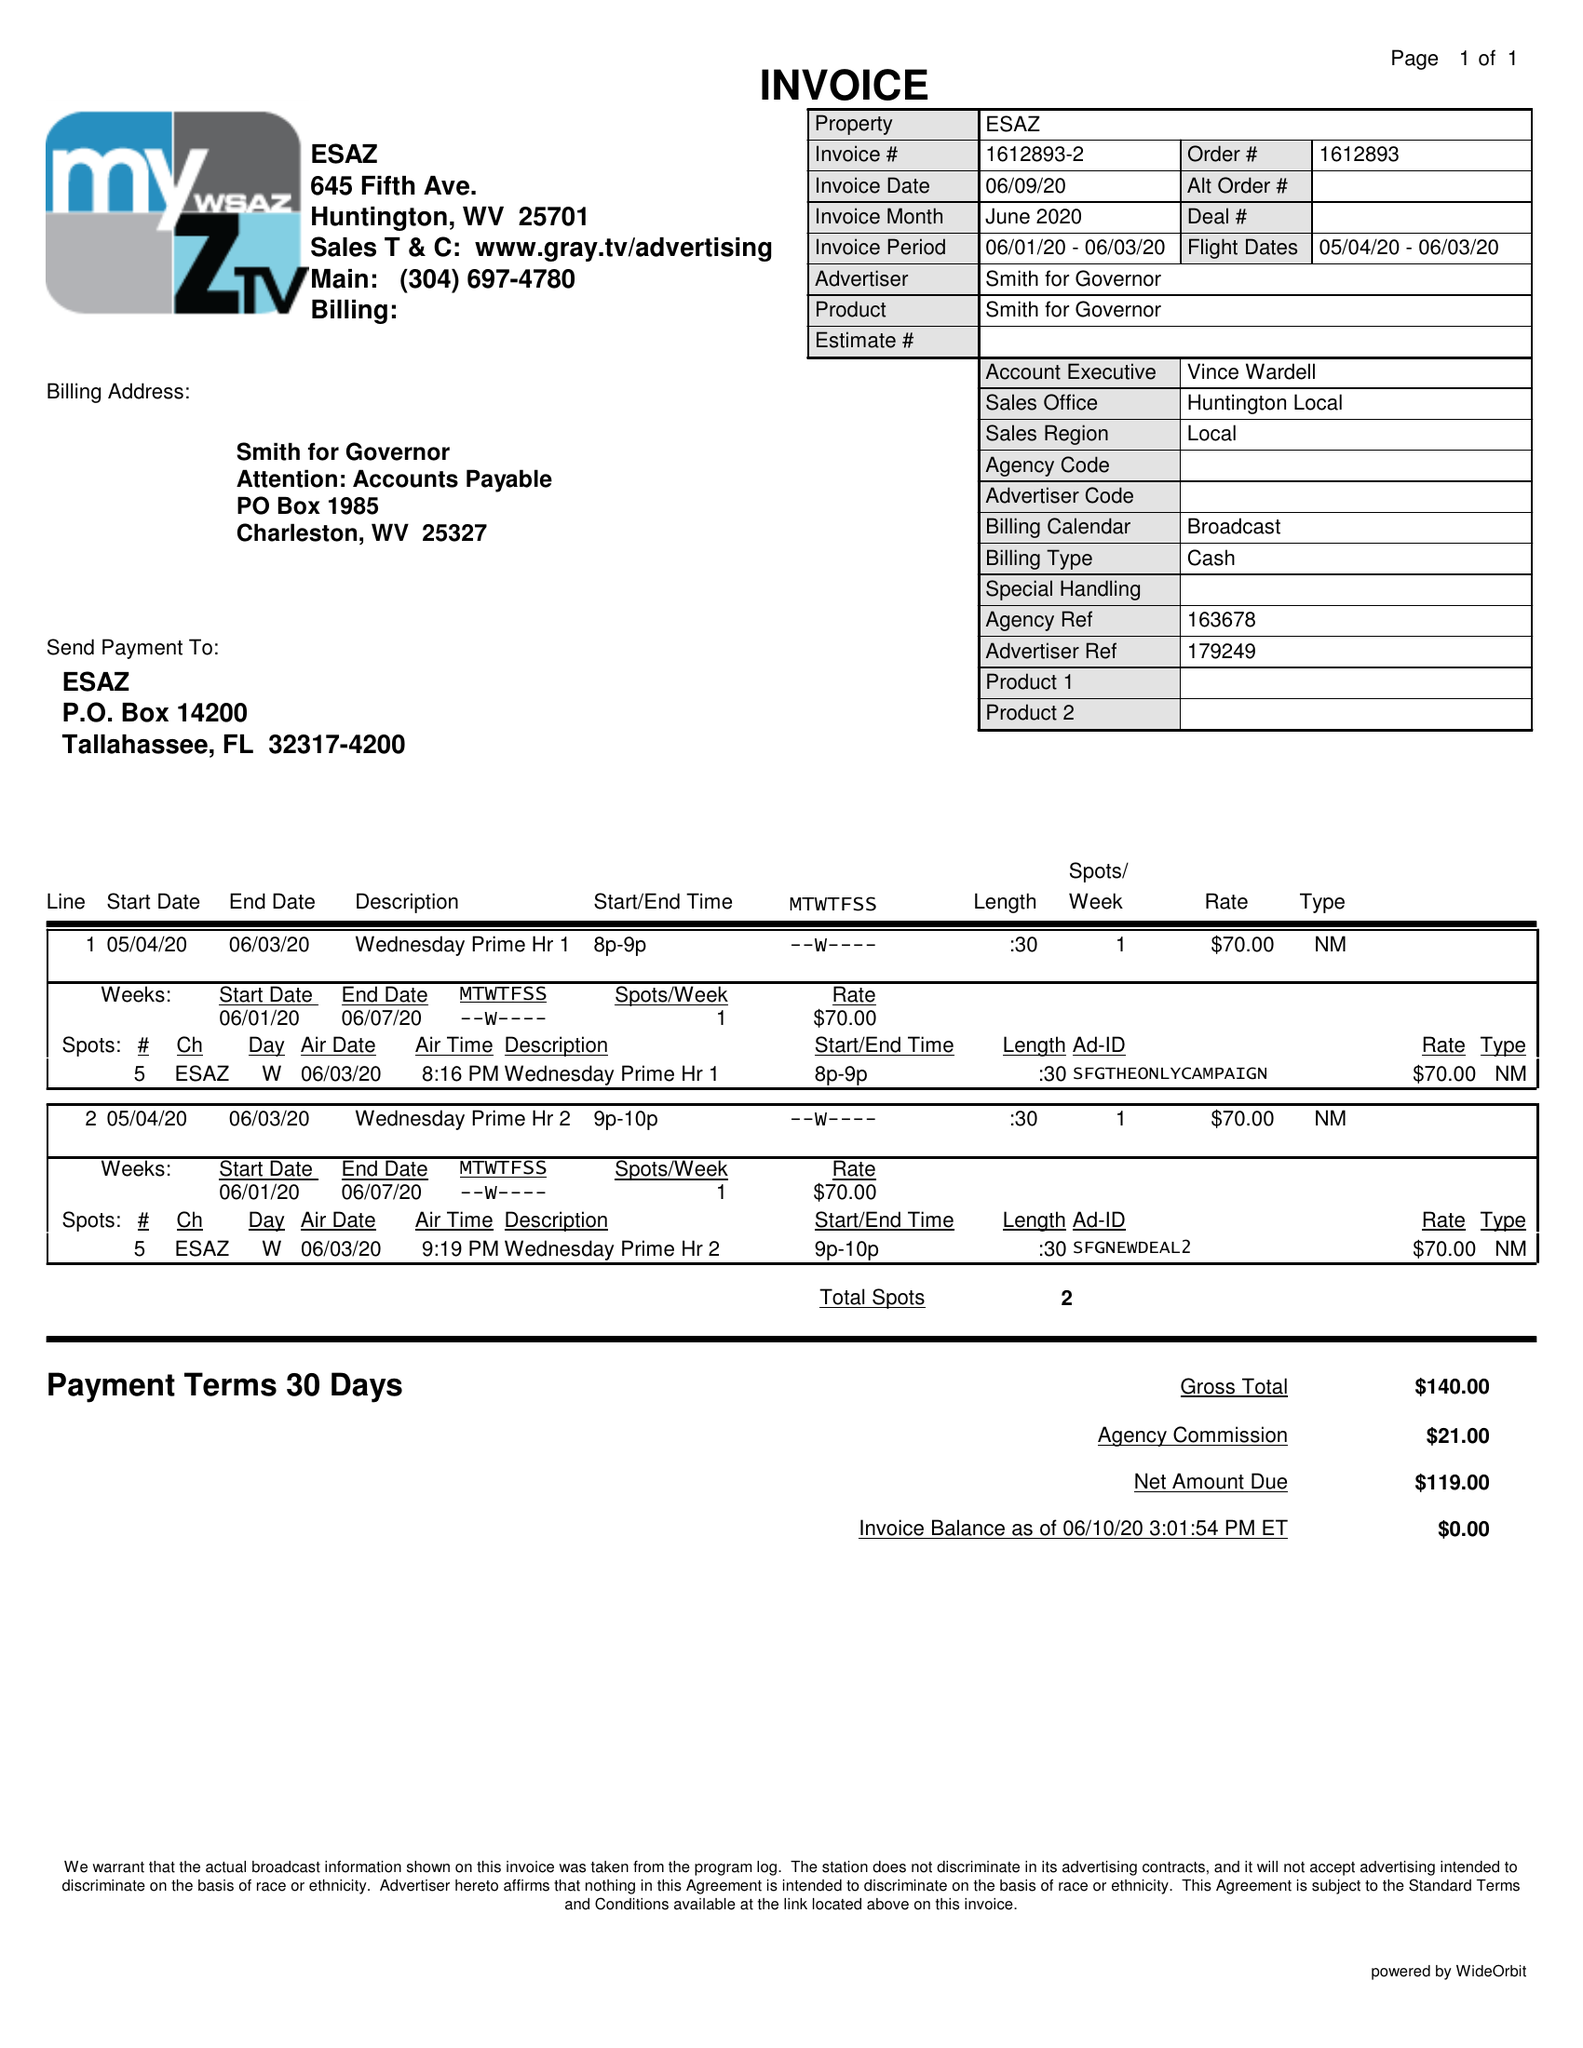What is the value for the flight_from?
Answer the question using a single word or phrase. 05/04/20 